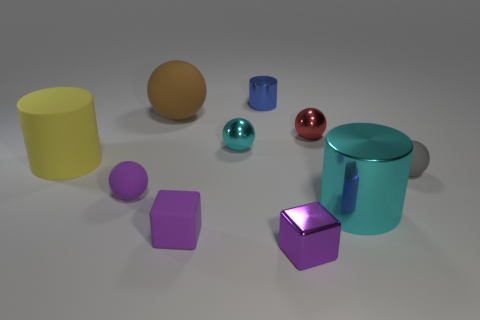What number of other things are there of the same size as the red thing?
Provide a short and direct response. 6. There is a large object that is left of the tiny purple rubber object behind the cyan object that is on the right side of the purple shiny block; what shape is it?
Your response must be concise. Cylinder. There is a gray thing; is its size the same as the shiny cylinder to the right of the small purple metal block?
Your answer should be very brief. No. What is the color of the tiny thing that is in front of the large cyan cylinder and behind the small purple shiny block?
Make the answer very short. Purple. What number of other things are there of the same shape as the brown object?
Keep it short and to the point. 4. There is a small rubber object that is left of the large brown ball; does it have the same color as the block behind the metallic block?
Your answer should be compact. Yes. There is a matte ball that is to the right of the tiny red metallic thing; is its size the same as the cyan shiny object that is behind the big yellow cylinder?
Give a very brief answer. Yes. There is a large cyan object in front of the small rubber sphere that is in front of the small rubber ball right of the big cyan shiny cylinder; what is it made of?
Your response must be concise. Metal. Is the small cyan metal object the same shape as the small red shiny object?
Offer a very short reply. Yes. There is a small cyan object that is the same shape as the brown rubber thing; what is it made of?
Your answer should be very brief. Metal. 